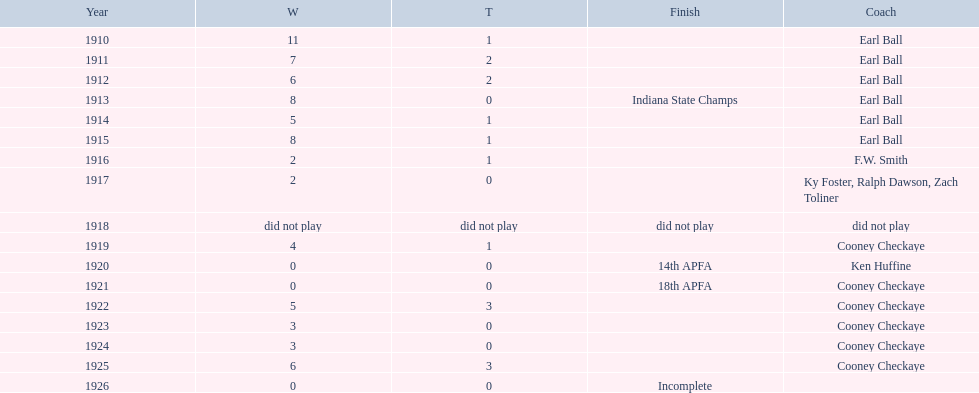Who coached the muncie flyers to an indiana state championship? Earl Ball. 